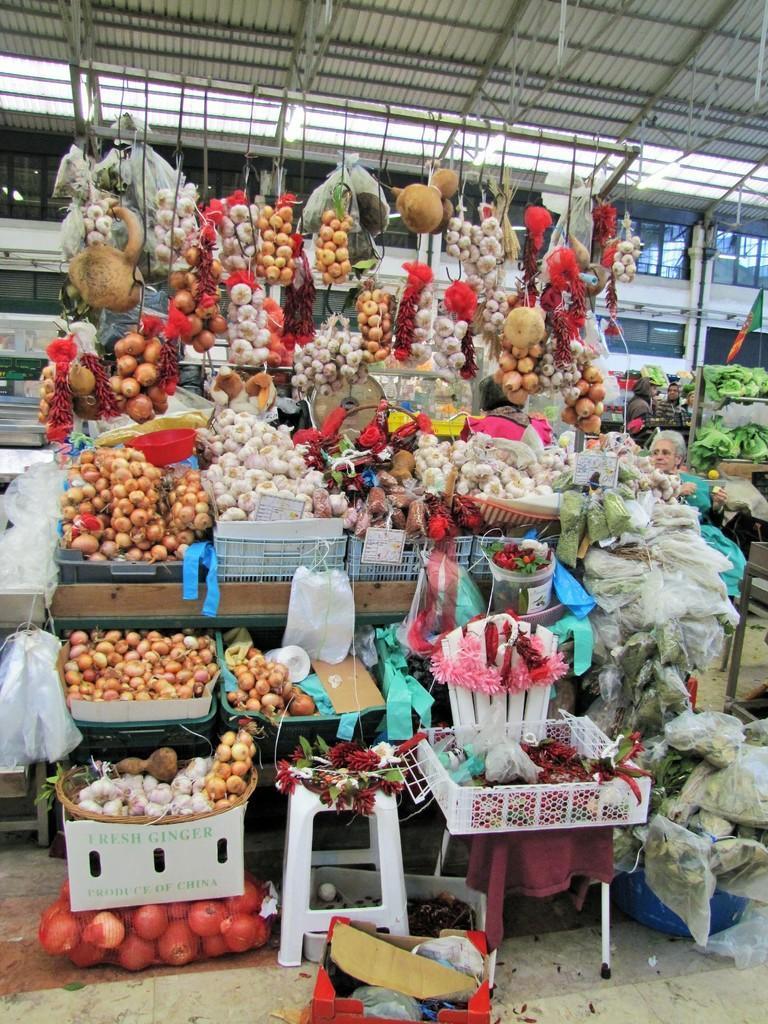In one or two sentences, can you explain what this image depicts? In the middle of the image we can see some fruits and vegetables on tables and baskets. Behind them we can see a person. At the top of the image we can see a roof. 